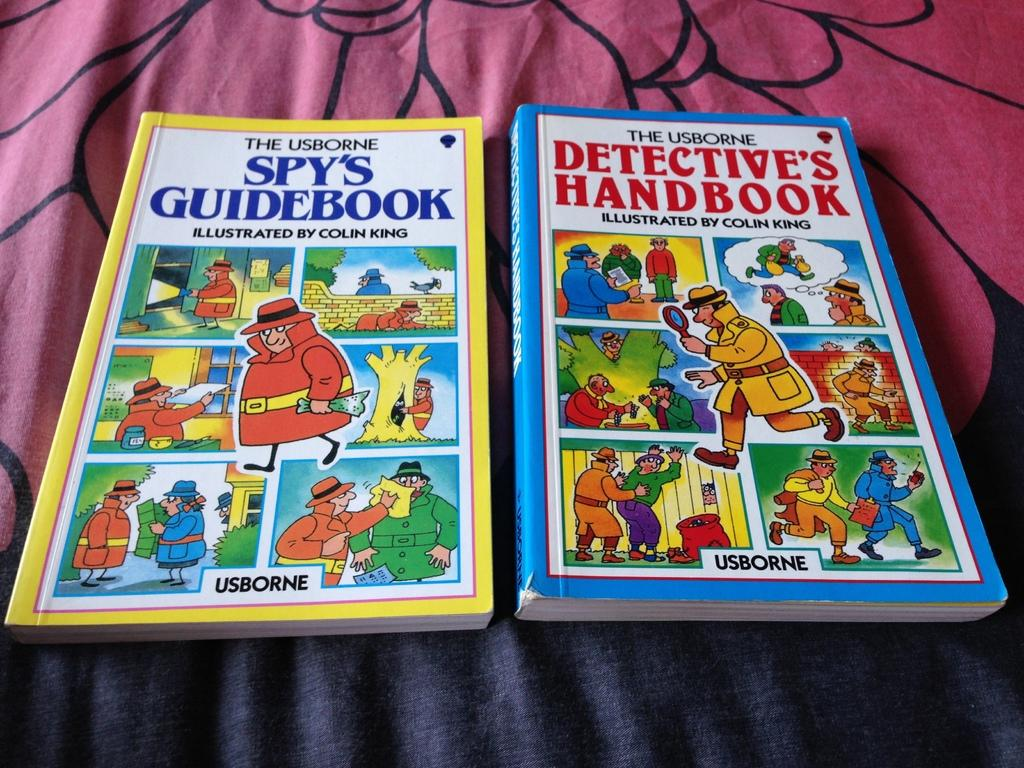<image>
Write a terse but informative summary of the picture. Two books next to each other, the yellow one called The Usborne Spy's Guidebook. 